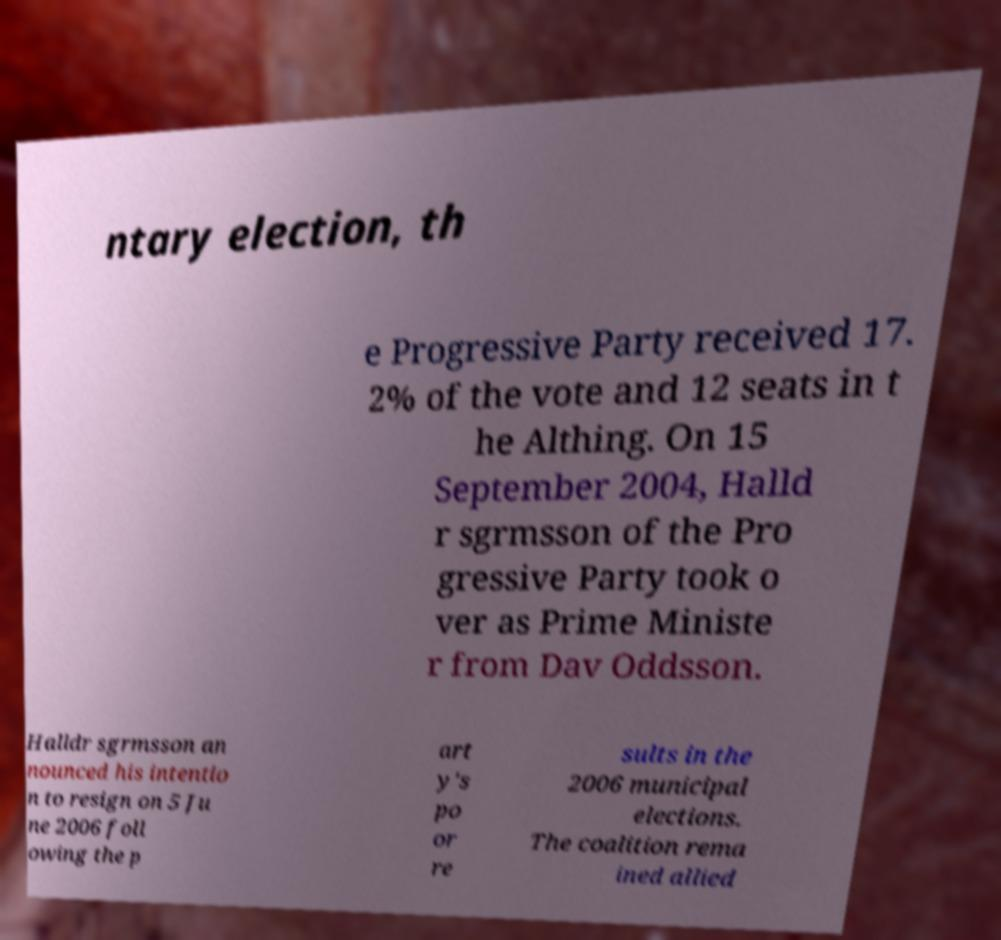I need the written content from this picture converted into text. Can you do that? ntary election, th e Progressive Party received 17. 2% of the vote and 12 seats in t he Althing. On 15 September 2004, Halld r sgrmsson of the Pro gressive Party took o ver as Prime Ministe r from Dav Oddsson. Halldr sgrmsson an nounced his intentio n to resign on 5 Ju ne 2006 foll owing the p art y's po or re sults in the 2006 municipal elections. The coalition rema ined allied 